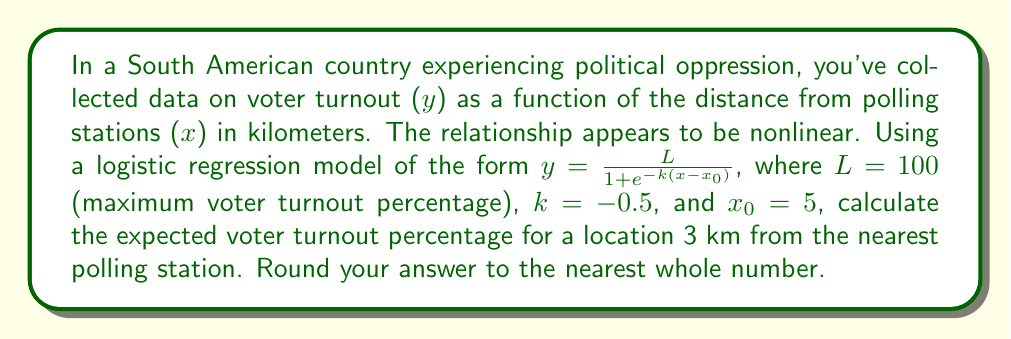What is the answer to this math problem? To solve this problem, we'll follow these steps:

1) We're given the logistic regression model:

   $y = \frac{L}{1 + e^{-k(x-x_0)}}$

2) We're also given the following parameters:
   L = 100 (maximum voter turnout percentage)
   k = -0.5
   $x_0$ = 5
   x = 3 (the distance we're calculating for)

3) Let's substitute these values into our equation:

   $y = \frac{100}{1 + e^{-(-0.5)(3-5)}}$

4) Simplify the expression inside the exponential:
   
   $y = \frac{100}{1 + e^{-(-0.5)(-2)}}$
   
   $y = \frac{100}{1 + e^{1}}$

5) Calculate $e^1$:
   
   $y = \frac{100}{1 + 2.71828...}$

6) Add 1 to 2.71828... in the denominator:
   
   $y = \frac{100}{3.71828...}$

7) Divide 100 by 3.71828...:
   
   $y ≈ 26.8941...$

8) Round to the nearest whole number:
   
   $y ≈ 27$

Therefore, the expected voter turnout percentage for a location 3 km from the nearest polling station is approximately 27%.
Answer: 27% 